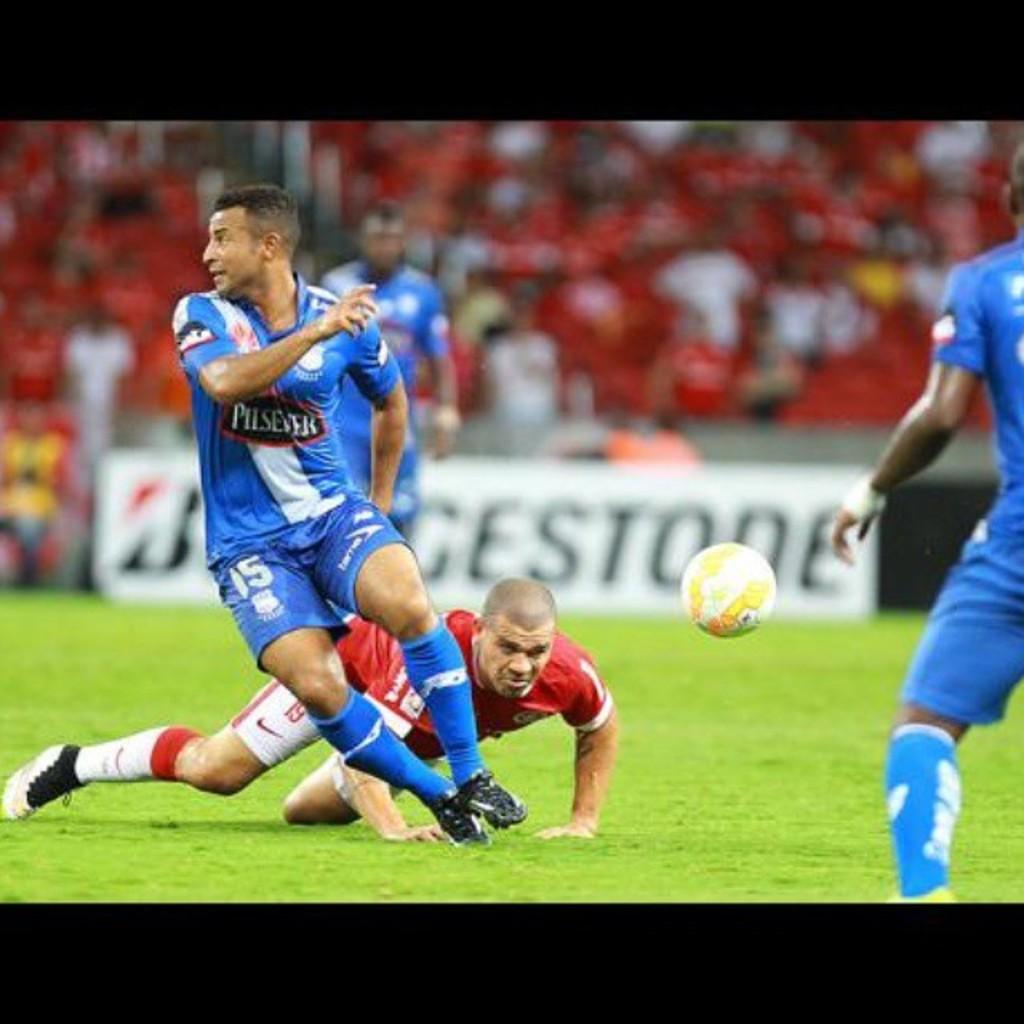What is the jersey number of the red player?
Provide a succinct answer. 19. What number is the blue player?
Your answer should be very brief. 15. 